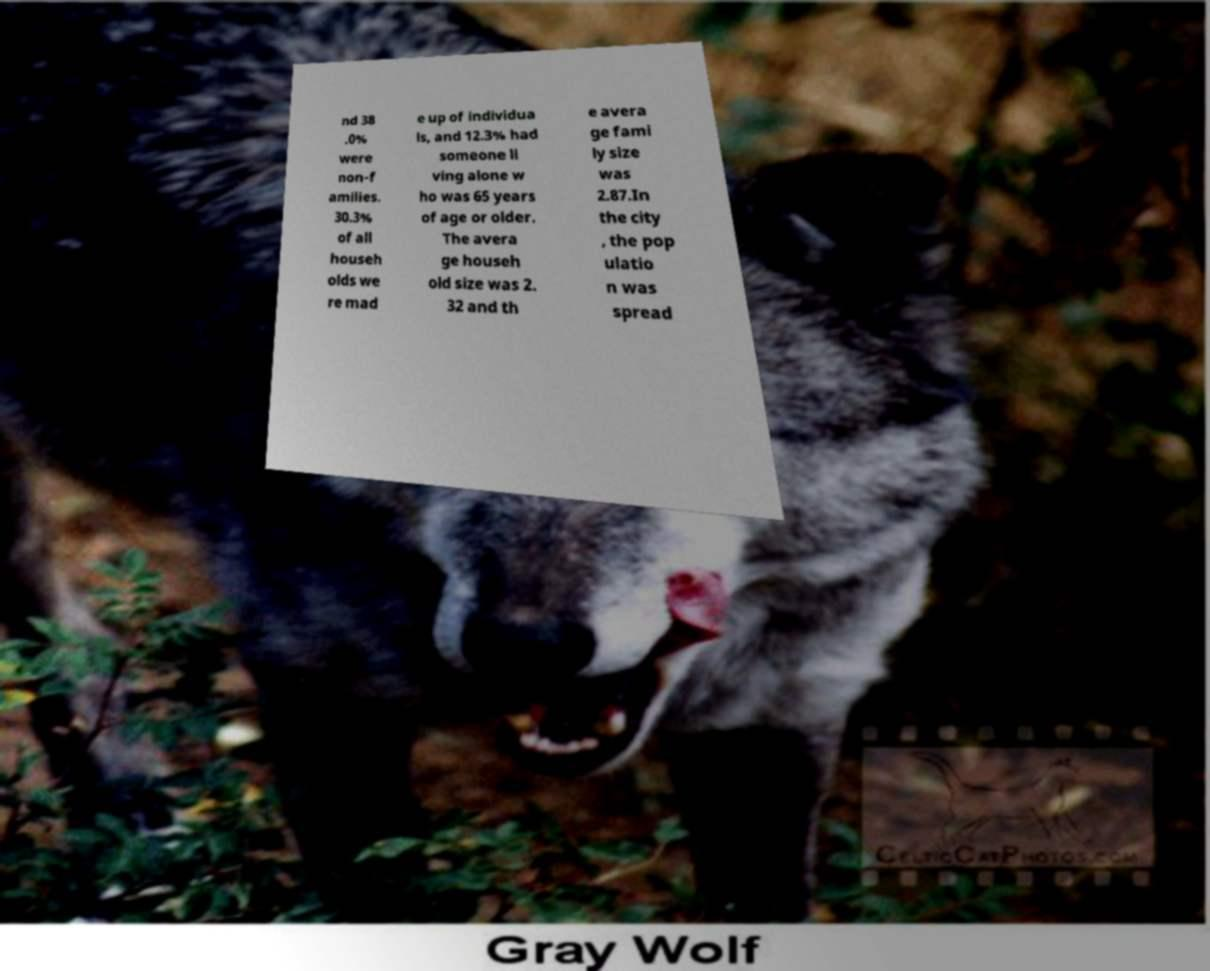There's text embedded in this image that I need extracted. Can you transcribe it verbatim? nd 38 .0% were non-f amilies. 30.3% of all househ olds we re mad e up of individua ls, and 12.3% had someone li ving alone w ho was 65 years of age or older. The avera ge househ old size was 2. 32 and th e avera ge fami ly size was 2.87.In the city , the pop ulatio n was spread 